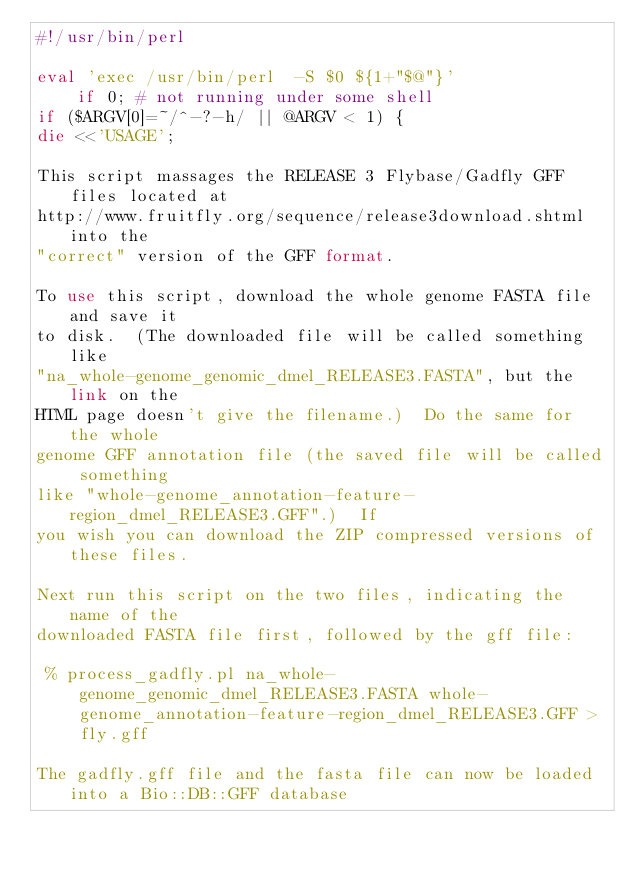<code> <loc_0><loc_0><loc_500><loc_500><_Perl_>#!/usr/bin/perl 

eval 'exec /usr/bin/perl  -S $0 ${1+"$@"}'
    if 0; # not running under some shell
if ($ARGV[0]=~/^-?-h/ || @ARGV < 1) {
die <<'USAGE';

This script massages the RELEASE 3 Flybase/Gadfly GFF files located at
http://www.fruitfly.org/sequence/release3download.shtml into the
"correct" version of the GFF format.

To use this script, download the whole genome FASTA file and save it
to disk.  (The downloaded file will be called something like
"na_whole-genome_genomic_dmel_RELEASE3.FASTA", but the link on the
HTML page doesn't give the filename.)  Do the same for the whole
genome GFF annotation file (the saved file will be called something
like "whole-genome_annotation-feature-region_dmel_RELEASE3.GFF".)  If
you wish you can download the ZIP compressed versions of these files.

Next run this script on the two files, indicating the name of the
downloaded FASTA file first, followed by the gff file:

 % process_gadfly.pl na_whole-genome_genomic_dmel_RELEASE3.FASTA whole-genome_annotation-feature-region_dmel_RELEASE3.GFF > fly.gff

The gadfly.gff file and the fasta file can now be loaded into a Bio::DB::GFF database</code> 